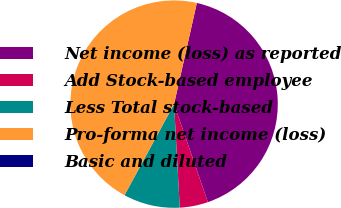Convert chart to OTSL. <chart><loc_0><loc_0><loc_500><loc_500><pie_chart><fcel>Net income (loss) as reported<fcel>Add Stock-based employee<fcel>Less Total stock-based<fcel>Pro-forma net income (loss)<fcel>Basic and diluted<nl><fcel>41.19%<fcel>4.41%<fcel>8.81%<fcel>45.59%<fcel>0.0%<nl></chart> 